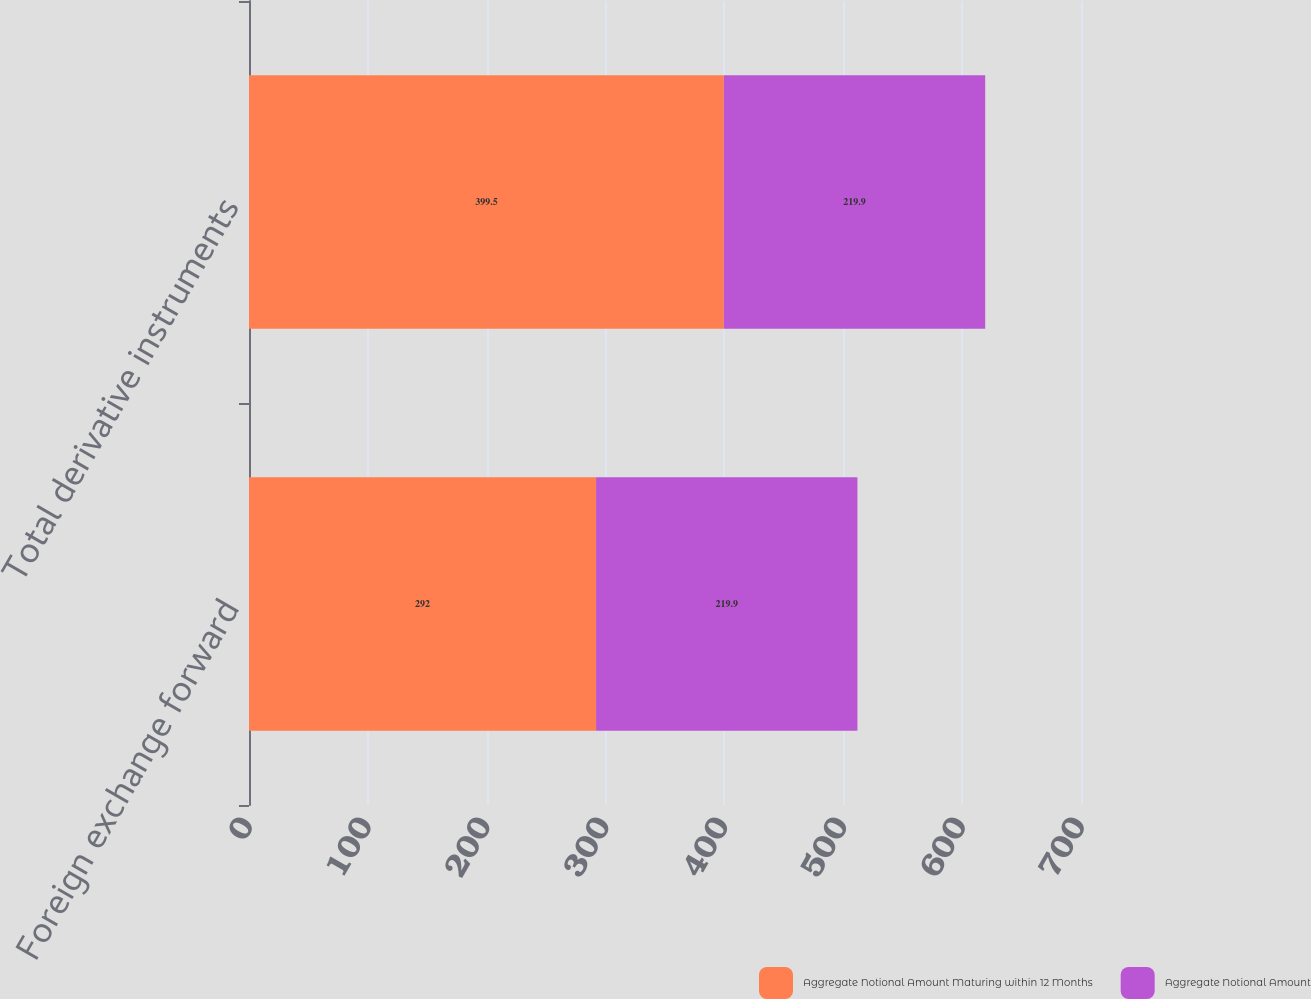Convert chart to OTSL. <chart><loc_0><loc_0><loc_500><loc_500><stacked_bar_chart><ecel><fcel>Foreign exchange forward<fcel>Total derivative instruments<nl><fcel>Aggregate Notional Amount Maturing within 12 Months<fcel>292<fcel>399.5<nl><fcel>Aggregate Notional Amount<fcel>219.9<fcel>219.9<nl></chart> 